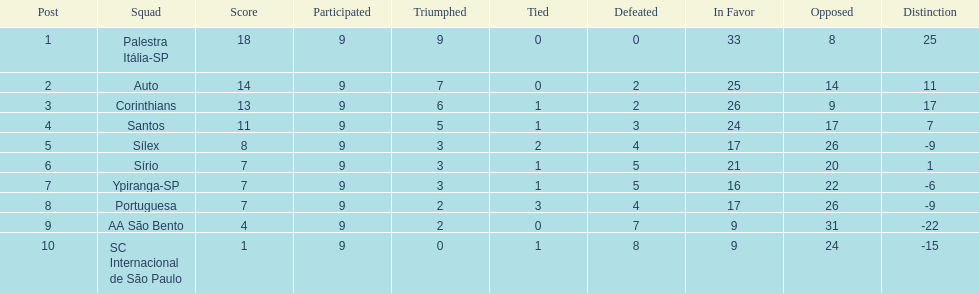In 1926 brazilian football,what was the total number of points scored? 90. 